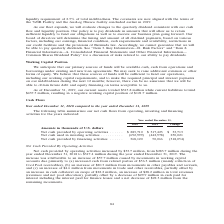From Gaslog's financial document, What are the components of net cash flows recorded? The document contains multiple relevant values: Operating activities, Investing activities, Financing activities. From the document: "in thousands of U.S. dollars Net cash provided by operating activities . $ 283,710 $ 317,423 $ 33,713 Net cash used in investing activities . (692,999..." Also, What was the reason for the decrease in net cash used in investing activites? Based on the financial document, the answer is The decrease is attributable to a decrease of $203.7 million in net cash used in payments for the construction costs of newbuildings and other fixed assets, a net increase of $45.5 million in cash from short-term investments in the year ended December 31, 2019, compared to the same period of 2018 and an increase of $0.8 million in cash from interest income.. Also, By how much did the bank loan repayment change? Based on the financial document, the answer is Increase of $316.0 million. Additionally, Which year was the net cash provided by operating activities higher? According to the financial document, 2019. The relevant text states: "Year ended December 31, 2018 2019 Change..." Also, can you calculate: What was the percentage change in net cash provided by operating activities from 2018 to 2019? To answer this question, I need to perform calculations using the financial data. The calculation is: ($317,423- $283,710)/$283,710 , which equals 11.88 (percentage). This is based on the information: "sh provided by operating activities . $ 283,710 $ 317,423 $ 33,713 Net cash used in investing activities . (692,999) (442,978) 250,021 Net cash provided by f ars Net cash provided by operating activit..." The key data points involved are: 283,710, 317,423. Also, can you calculate: What was the percentage change in net cash provided by financing activities from 2018 to 2019? To answer this question, I need to perform calculations using the financial data. The calculation is: (50,066 - 368,120)/368,120 , which equals -86.4 (percentage). This is based on the information: "t cash provided by financing activities . 368,120 50,066 (318,054) 0,021 Net cash provided by financing activities . 368,120 50,066 (318,054)..." The key data points involved are: 368,120, 50,066. 